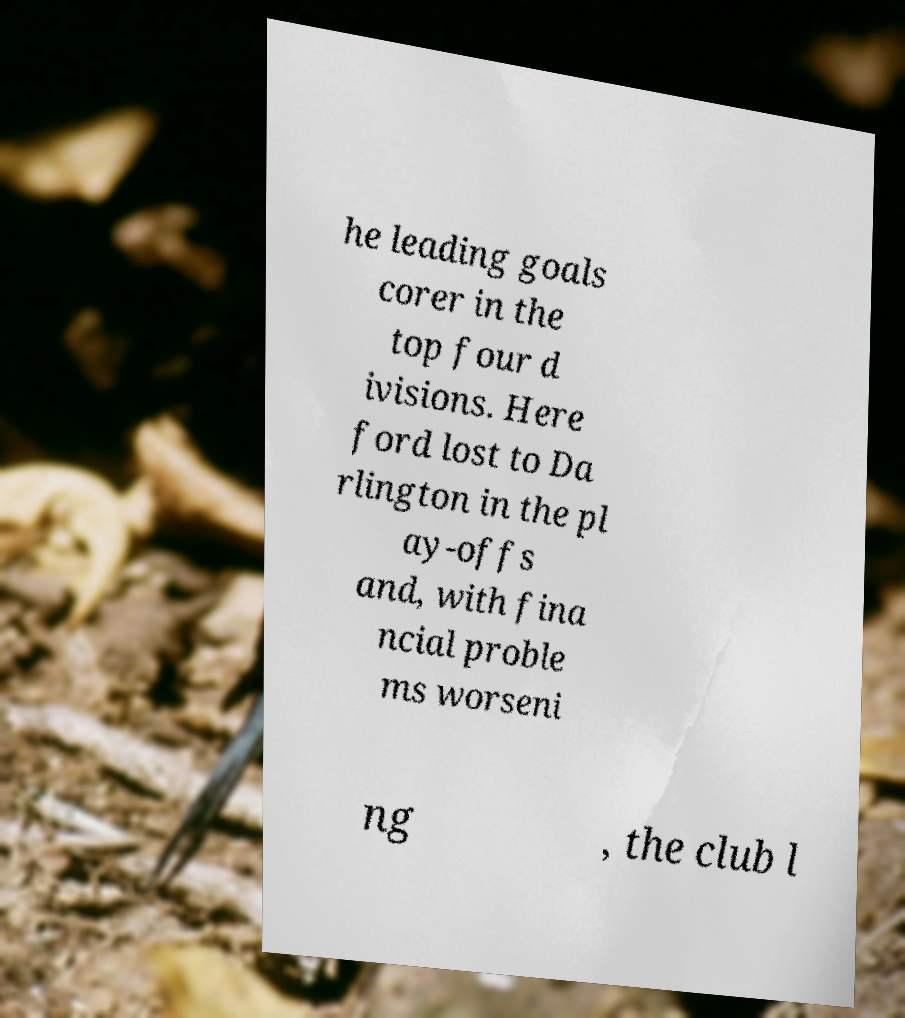Could you extract and type out the text from this image? he leading goals corer in the top four d ivisions. Here ford lost to Da rlington in the pl ay-offs and, with fina ncial proble ms worseni ng , the club l 